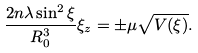Convert formula to latex. <formula><loc_0><loc_0><loc_500><loc_500>\frac { 2 n \lambda \sin ^ { 2 } \xi } { R _ { 0 } ^ { 3 } } \xi _ { z } = \pm \mu \sqrt { V ( \xi ) } .</formula> 